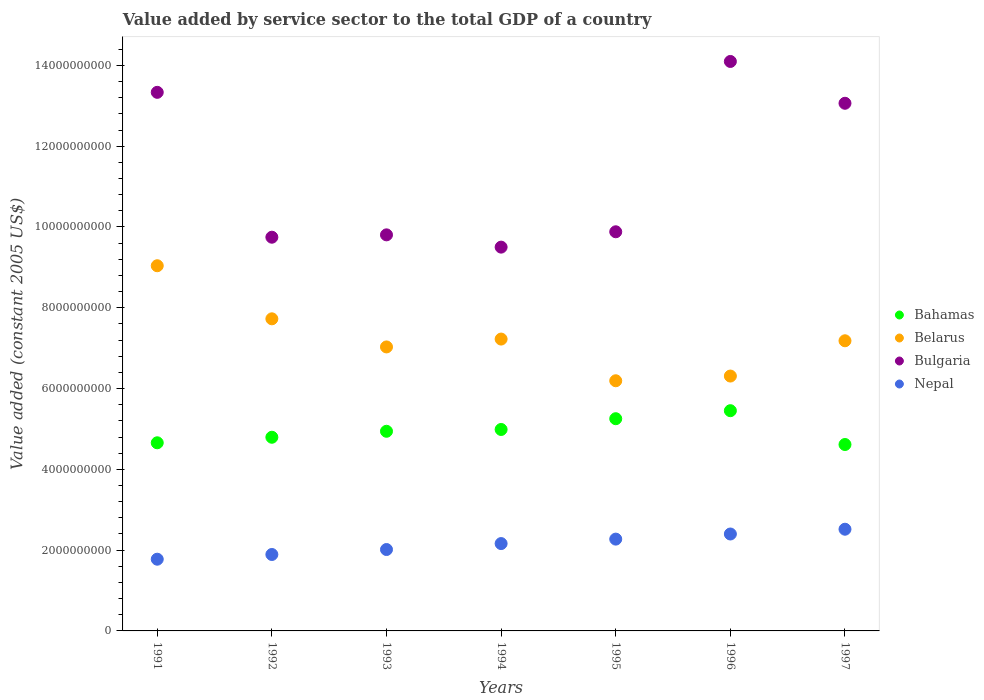What is the value added by service sector in Bulgaria in 1992?
Your answer should be very brief. 9.75e+09. Across all years, what is the maximum value added by service sector in Nepal?
Your answer should be very brief. 2.52e+09. Across all years, what is the minimum value added by service sector in Nepal?
Offer a very short reply. 1.78e+09. In which year was the value added by service sector in Nepal maximum?
Give a very brief answer. 1997. In which year was the value added by service sector in Nepal minimum?
Give a very brief answer. 1991. What is the total value added by service sector in Nepal in the graph?
Keep it short and to the point. 1.50e+1. What is the difference between the value added by service sector in Bahamas in 1992 and that in 1994?
Keep it short and to the point. -1.93e+08. What is the difference between the value added by service sector in Bahamas in 1993 and the value added by service sector in Bulgaria in 1994?
Keep it short and to the point. -4.56e+09. What is the average value added by service sector in Bahamas per year?
Provide a succinct answer. 4.96e+09. In the year 1991, what is the difference between the value added by service sector in Belarus and value added by service sector in Bulgaria?
Your response must be concise. -4.29e+09. In how many years, is the value added by service sector in Bahamas greater than 4000000000 US$?
Offer a terse response. 7. What is the ratio of the value added by service sector in Nepal in 1991 to that in 1994?
Offer a terse response. 0.82. What is the difference between the highest and the second highest value added by service sector in Bulgaria?
Your answer should be compact. 7.64e+08. What is the difference between the highest and the lowest value added by service sector in Bulgaria?
Offer a very short reply. 4.60e+09. In how many years, is the value added by service sector in Nepal greater than the average value added by service sector in Nepal taken over all years?
Your answer should be very brief. 4. Is the sum of the value added by service sector in Belarus in 1992 and 1997 greater than the maximum value added by service sector in Nepal across all years?
Make the answer very short. Yes. Is it the case that in every year, the sum of the value added by service sector in Belarus and value added by service sector in Bulgaria  is greater than the value added by service sector in Nepal?
Offer a terse response. Yes. Does the value added by service sector in Belarus monotonically increase over the years?
Make the answer very short. No. How many dotlines are there?
Your response must be concise. 4. Does the graph contain any zero values?
Ensure brevity in your answer.  No. Does the graph contain grids?
Your response must be concise. No. What is the title of the graph?
Your response must be concise. Value added by service sector to the total GDP of a country. What is the label or title of the Y-axis?
Keep it short and to the point. Value added (constant 2005 US$). What is the Value added (constant 2005 US$) of Bahamas in 1991?
Offer a terse response. 4.66e+09. What is the Value added (constant 2005 US$) of Belarus in 1991?
Your answer should be compact. 9.04e+09. What is the Value added (constant 2005 US$) of Bulgaria in 1991?
Your answer should be very brief. 1.33e+1. What is the Value added (constant 2005 US$) of Nepal in 1991?
Make the answer very short. 1.78e+09. What is the Value added (constant 2005 US$) of Bahamas in 1992?
Keep it short and to the point. 4.79e+09. What is the Value added (constant 2005 US$) of Belarus in 1992?
Ensure brevity in your answer.  7.73e+09. What is the Value added (constant 2005 US$) of Bulgaria in 1992?
Your answer should be compact. 9.75e+09. What is the Value added (constant 2005 US$) in Nepal in 1992?
Your answer should be very brief. 1.89e+09. What is the Value added (constant 2005 US$) of Bahamas in 1993?
Offer a terse response. 4.94e+09. What is the Value added (constant 2005 US$) of Belarus in 1993?
Ensure brevity in your answer.  7.03e+09. What is the Value added (constant 2005 US$) of Bulgaria in 1993?
Make the answer very short. 9.80e+09. What is the Value added (constant 2005 US$) of Nepal in 1993?
Offer a very short reply. 2.01e+09. What is the Value added (constant 2005 US$) of Bahamas in 1994?
Provide a short and direct response. 4.99e+09. What is the Value added (constant 2005 US$) in Belarus in 1994?
Offer a very short reply. 7.22e+09. What is the Value added (constant 2005 US$) of Bulgaria in 1994?
Make the answer very short. 9.50e+09. What is the Value added (constant 2005 US$) of Nepal in 1994?
Make the answer very short. 2.16e+09. What is the Value added (constant 2005 US$) of Bahamas in 1995?
Your answer should be compact. 5.25e+09. What is the Value added (constant 2005 US$) in Belarus in 1995?
Ensure brevity in your answer.  6.19e+09. What is the Value added (constant 2005 US$) of Bulgaria in 1995?
Your answer should be compact. 9.88e+09. What is the Value added (constant 2005 US$) in Nepal in 1995?
Make the answer very short. 2.27e+09. What is the Value added (constant 2005 US$) of Bahamas in 1996?
Provide a short and direct response. 5.45e+09. What is the Value added (constant 2005 US$) in Belarus in 1996?
Keep it short and to the point. 6.31e+09. What is the Value added (constant 2005 US$) of Bulgaria in 1996?
Your answer should be compact. 1.41e+1. What is the Value added (constant 2005 US$) of Nepal in 1996?
Offer a very short reply. 2.40e+09. What is the Value added (constant 2005 US$) in Bahamas in 1997?
Keep it short and to the point. 4.61e+09. What is the Value added (constant 2005 US$) of Belarus in 1997?
Keep it short and to the point. 7.18e+09. What is the Value added (constant 2005 US$) in Bulgaria in 1997?
Keep it short and to the point. 1.31e+1. What is the Value added (constant 2005 US$) in Nepal in 1997?
Make the answer very short. 2.52e+09. Across all years, what is the maximum Value added (constant 2005 US$) in Bahamas?
Your response must be concise. 5.45e+09. Across all years, what is the maximum Value added (constant 2005 US$) of Belarus?
Your answer should be very brief. 9.04e+09. Across all years, what is the maximum Value added (constant 2005 US$) of Bulgaria?
Provide a succinct answer. 1.41e+1. Across all years, what is the maximum Value added (constant 2005 US$) of Nepal?
Offer a terse response. 2.52e+09. Across all years, what is the minimum Value added (constant 2005 US$) in Bahamas?
Offer a very short reply. 4.61e+09. Across all years, what is the minimum Value added (constant 2005 US$) of Belarus?
Ensure brevity in your answer.  6.19e+09. Across all years, what is the minimum Value added (constant 2005 US$) of Bulgaria?
Make the answer very short. 9.50e+09. Across all years, what is the minimum Value added (constant 2005 US$) of Nepal?
Make the answer very short. 1.78e+09. What is the total Value added (constant 2005 US$) of Bahamas in the graph?
Keep it short and to the point. 3.47e+1. What is the total Value added (constant 2005 US$) of Belarus in the graph?
Your answer should be very brief. 5.07e+1. What is the total Value added (constant 2005 US$) in Bulgaria in the graph?
Offer a very short reply. 7.94e+1. What is the total Value added (constant 2005 US$) of Nepal in the graph?
Your response must be concise. 1.50e+1. What is the difference between the Value added (constant 2005 US$) of Bahamas in 1991 and that in 1992?
Give a very brief answer. -1.37e+08. What is the difference between the Value added (constant 2005 US$) of Belarus in 1991 and that in 1992?
Make the answer very short. 1.31e+09. What is the difference between the Value added (constant 2005 US$) of Bulgaria in 1991 and that in 1992?
Offer a very short reply. 3.59e+09. What is the difference between the Value added (constant 2005 US$) in Nepal in 1991 and that in 1992?
Provide a short and direct response. -1.17e+08. What is the difference between the Value added (constant 2005 US$) in Bahamas in 1991 and that in 1993?
Make the answer very short. -2.85e+08. What is the difference between the Value added (constant 2005 US$) of Belarus in 1991 and that in 1993?
Keep it short and to the point. 2.01e+09. What is the difference between the Value added (constant 2005 US$) of Bulgaria in 1991 and that in 1993?
Your answer should be very brief. 3.53e+09. What is the difference between the Value added (constant 2005 US$) in Nepal in 1991 and that in 1993?
Your answer should be compact. -2.40e+08. What is the difference between the Value added (constant 2005 US$) of Bahamas in 1991 and that in 1994?
Provide a succinct answer. -3.30e+08. What is the difference between the Value added (constant 2005 US$) of Belarus in 1991 and that in 1994?
Offer a terse response. 1.82e+09. What is the difference between the Value added (constant 2005 US$) in Bulgaria in 1991 and that in 1994?
Provide a succinct answer. 3.83e+09. What is the difference between the Value added (constant 2005 US$) of Nepal in 1991 and that in 1994?
Your response must be concise. -3.87e+08. What is the difference between the Value added (constant 2005 US$) of Bahamas in 1991 and that in 1995?
Keep it short and to the point. -5.96e+08. What is the difference between the Value added (constant 2005 US$) of Belarus in 1991 and that in 1995?
Provide a succinct answer. 2.85e+09. What is the difference between the Value added (constant 2005 US$) in Bulgaria in 1991 and that in 1995?
Provide a succinct answer. 3.45e+09. What is the difference between the Value added (constant 2005 US$) of Nepal in 1991 and that in 1995?
Give a very brief answer. -4.97e+08. What is the difference between the Value added (constant 2005 US$) in Bahamas in 1991 and that in 1996?
Offer a terse response. -7.95e+08. What is the difference between the Value added (constant 2005 US$) of Belarus in 1991 and that in 1996?
Your response must be concise. 2.73e+09. What is the difference between the Value added (constant 2005 US$) in Bulgaria in 1991 and that in 1996?
Your answer should be compact. -7.64e+08. What is the difference between the Value added (constant 2005 US$) in Nepal in 1991 and that in 1996?
Your answer should be very brief. -6.24e+08. What is the difference between the Value added (constant 2005 US$) in Bahamas in 1991 and that in 1997?
Make the answer very short. 4.26e+07. What is the difference between the Value added (constant 2005 US$) of Belarus in 1991 and that in 1997?
Provide a succinct answer. 1.86e+09. What is the difference between the Value added (constant 2005 US$) in Bulgaria in 1991 and that in 1997?
Your response must be concise. 2.71e+08. What is the difference between the Value added (constant 2005 US$) in Nepal in 1991 and that in 1997?
Your response must be concise. -7.42e+08. What is the difference between the Value added (constant 2005 US$) of Bahamas in 1992 and that in 1993?
Your answer should be compact. -1.48e+08. What is the difference between the Value added (constant 2005 US$) of Belarus in 1992 and that in 1993?
Offer a terse response. 6.96e+08. What is the difference between the Value added (constant 2005 US$) of Bulgaria in 1992 and that in 1993?
Ensure brevity in your answer.  -5.85e+07. What is the difference between the Value added (constant 2005 US$) in Nepal in 1992 and that in 1993?
Your response must be concise. -1.23e+08. What is the difference between the Value added (constant 2005 US$) in Bahamas in 1992 and that in 1994?
Offer a very short reply. -1.93e+08. What is the difference between the Value added (constant 2005 US$) in Belarus in 1992 and that in 1994?
Provide a short and direct response. 5.01e+08. What is the difference between the Value added (constant 2005 US$) in Bulgaria in 1992 and that in 1994?
Your answer should be very brief. 2.45e+08. What is the difference between the Value added (constant 2005 US$) in Nepal in 1992 and that in 1994?
Provide a short and direct response. -2.70e+08. What is the difference between the Value added (constant 2005 US$) in Bahamas in 1992 and that in 1995?
Make the answer very short. -4.59e+08. What is the difference between the Value added (constant 2005 US$) in Belarus in 1992 and that in 1995?
Provide a short and direct response. 1.53e+09. What is the difference between the Value added (constant 2005 US$) in Bulgaria in 1992 and that in 1995?
Give a very brief answer. -1.35e+08. What is the difference between the Value added (constant 2005 US$) in Nepal in 1992 and that in 1995?
Offer a very short reply. -3.81e+08. What is the difference between the Value added (constant 2005 US$) of Bahamas in 1992 and that in 1996?
Ensure brevity in your answer.  -6.57e+08. What is the difference between the Value added (constant 2005 US$) of Belarus in 1992 and that in 1996?
Offer a terse response. 1.42e+09. What is the difference between the Value added (constant 2005 US$) in Bulgaria in 1992 and that in 1996?
Ensure brevity in your answer.  -4.35e+09. What is the difference between the Value added (constant 2005 US$) of Nepal in 1992 and that in 1996?
Make the answer very short. -5.07e+08. What is the difference between the Value added (constant 2005 US$) of Bahamas in 1992 and that in 1997?
Make the answer very short. 1.80e+08. What is the difference between the Value added (constant 2005 US$) in Belarus in 1992 and that in 1997?
Provide a short and direct response. 5.43e+08. What is the difference between the Value added (constant 2005 US$) in Bulgaria in 1992 and that in 1997?
Your response must be concise. -3.32e+09. What is the difference between the Value added (constant 2005 US$) in Nepal in 1992 and that in 1997?
Make the answer very short. -6.26e+08. What is the difference between the Value added (constant 2005 US$) of Bahamas in 1993 and that in 1994?
Make the answer very short. -4.47e+07. What is the difference between the Value added (constant 2005 US$) of Belarus in 1993 and that in 1994?
Make the answer very short. -1.95e+08. What is the difference between the Value added (constant 2005 US$) in Bulgaria in 1993 and that in 1994?
Provide a short and direct response. 3.04e+08. What is the difference between the Value added (constant 2005 US$) in Nepal in 1993 and that in 1994?
Make the answer very short. -1.47e+08. What is the difference between the Value added (constant 2005 US$) of Bahamas in 1993 and that in 1995?
Make the answer very short. -3.11e+08. What is the difference between the Value added (constant 2005 US$) in Belarus in 1993 and that in 1995?
Provide a succinct answer. 8.37e+08. What is the difference between the Value added (constant 2005 US$) of Bulgaria in 1993 and that in 1995?
Provide a succinct answer. -7.61e+07. What is the difference between the Value added (constant 2005 US$) of Nepal in 1993 and that in 1995?
Make the answer very short. -2.58e+08. What is the difference between the Value added (constant 2005 US$) in Bahamas in 1993 and that in 1996?
Ensure brevity in your answer.  -5.10e+08. What is the difference between the Value added (constant 2005 US$) in Belarus in 1993 and that in 1996?
Your response must be concise. 7.21e+08. What is the difference between the Value added (constant 2005 US$) in Bulgaria in 1993 and that in 1996?
Ensure brevity in your answer.  -4.29e+09. What is the difference between the Value added (constant 2005 US$) in Nepal in 1993 and that in 1996?
Offer a terse response. -3.84e+08. What is the difference between the Value added (constant 2005 US$) of Bahamas in 1993 and that in 1997?
Give a very brief answer. 3.28e+08. What is the difference between the Value added (constant 2005 US$) of Belarus in 1993 and that in 1997?
Provide a short and direct response. -1.52e+08. What is the difference between the Value added (constant 2005 US$) in Bulgaria in 1993 and that in 1997?
Make the answer very short. -3.26e+09. What is the difference between the Value added (constant 2005 US$) of Nepal in 1993 and that in 1997?
Make the answer very short. -5.03e+08. What is the difference between the Value added (constant 2005 US$) of Bahamas in 1994 and that in 1995?
Provide a short and direct response. -2.67e+08. What is the difference between the Value added (constant 2005 US$) of Belarus in 1994 and that in 1995?
Provide a succinct answer. 1.03e+09. What is the difference between the Value added (constant 2005 US$) of Bulgaria in 1994 and that in 1995?
Offer a very short reply. -3.80e+08. What is the difference between the Value added (constant 2005 US$) of Nepal in 1994 and that in 1995?
Your answer should be very brief. -1.10e+08. What is the difference between the Value added (constant 2005 US$) in Bahamas in 1994 and that in 1996?
Your response must be concise. -4.65e+08. What is the difference between the Value added (constant 2005 US$) in Belarus in 1994 and that in 1996?
Your answer should be compact. 9.15e+08. What is the difference between the Value added (constant 2005 US$) of Bulgaria in 1994 and that in 1996?
Ensure brevity in your answer.  -4.60e+09. What is the difference between the Value added (constant 2005 US$) in Nepal in 1994 and that in 1996?
Ensure brevity in your answer.  -2.37e+08. What is the difference between the Value added (constant 2005 US$) in Bahamas in 1994 and that in 1997?
Offer a very short reply. 3.72e+08. What is the difference between the Value added (constant 2005 US$) in Belarus in 1994 and that in 1997?
Offer a terse response. 4.22e+07. What is the difference between the Value added (constant 2005 US$) of Bulgaria in 1994 and that in 1997?
Offer a very short reply. -3.56e+09. What is the difference between the Value added (constant 2005 US$) of Nepal in 1994 and that in 1997?
Ensure brevity in your answer.  -3.55e+08. What is the difference between the Value added (constant 2005 US$) of Bahamas in 1995 and that in 1996?
Your answer should be very brief. -1.98e+08. What is the difference between the Value added (constant 2005 US$) in Belarus in 1995 and that in 1996?
Your answer should be very brief. -1.17e+08. What is the difference between the Value added (constant 2005 US$) of Bulgaria in 1995 and that in 1996?
Your answer should be very brief. -4.22e+09. What is the difference between the Value added (constant 2005 US$) of Nepal in 1995 and that in 1996?
Provide a succinct answer. -1.27e+08. What is the difference between the Value added (constant 2005 US$) of Bahamas in 1995 and that in 1997?
Ensure brevity in your answer.  6.39e+08. What is the difference between the Value added (constant 2005 US$) in Belarus in 1995 and that in 1997?
Your response must be concise. -9.90e+08. What is the difference between the Value added (constant 2005 US$) in Bulgaria in 1995 and that in 1997?
Your answer should be compact. -3.18e+09. What is the difference between the Value added (constant 2005 US$) of Nepal in 1995 and that in 1997?
Provide a short and direct response. -2.45e+08. What is the difference between the Value added (constant 2005 US$) in Bahamas in 1996 and that in 1997?
Provide a short and direct response. 8.37e+08. What is the difference between the Value added (constant 2005 US$) of Belarus in 1996 and that in 1997?
Your answer should be compact. -8.73e+08. What is the difference between the Value added (constant 2005 US$) of Bulgaria in 1996 and that in 1997?
Keep it short and to the point. 1.03e+09. What is the difference between the Value added (constant 2005 US$) in Nepal in 1996 and that in 1997?
Provide a succinct answer. -1.18e+08. What is the difference between the Value added (constant 2005 US$) of Bahamas in 1991 and the Value added (constant 2005 US$) of Belarus in 1992?
Your answer should be compact. -3.07e+09. What is the difference between the Value added (constant 2005 US$) of Bahamas in 1991 and the Value added (constant 2005 US$) of Bulgaria in 1992?
Your answer should be very brief. -5.09e+09. What is the difference between the Value added (constant 2005 US$) in Bahamas in 1991 and the Value added (constant 2005 US$) in Nepal in 1992?
Give a very brief answer. 2.77e+09. What is the difference between the Value added (constant 2005 US$) of Belarus in 1991 and the Value added (constant 2005 US$) of Bulgaria in 1992?
Ensure brevity in your answer.  -7.06e+08. What is the difference between the Value added (constant 2005 US$) of Belarus in 1991 and the Value added (constant 2005 US$) of Nepal in 1992?
Make the answer very short. 7.15e+09. What is the difference between the Value added (constant 2005 US$) of Bulgaria in 1991 and the Value added (constant 2005 US$) of Nepal in 1992?
Offer a very short reply. 1.14e+1. What is the difference between the Value added (constant 2005 US$) of Bahamas in 1991 and the Value added (constant 2005 US$) of Belarus in 1993?
Provide a succinct answer. -2.37e+09. What is the difference between the Value added (constant 2005 US$) in Bahamas in 1991 and the Value added (constant 2005 US$) in Bulgaria in 1993?
Provide a succinct answer. -5.15e+09. What is the difference between the Value added (constant 2005 US$) of Bahamas in 1991 and the Value added (constant 2005 US$) of Nepal in 1993?
Ensure brevity in your answer.  2.64e+09. What is the difference between the Value added (constant 2005 US$) of Belarus in 1991 and the Value added (constant 2005 US$) of Bulgaria in 1993?
Offer a very short reply. -7.65e+08. What is the difference between the Value added (constant 2005 US$) in Belarus in 1991 and the Value added (constant 2005 US$) in Nepal in 1993?
Keep it short and to the point. 7.03e+09. What is the difference between the Value added (constant 2005 US$) of Bulgaria in 1991 and the Value added (constant 2005 US$) of Nepal in 1993?
Offer a terse response. 1.13e+1. What is the difference between the Value added (constant 2005 US$) of Bahamas in 1991 and the Value added (constant 2005 US$) of Belarus in 1994?
Give a very brief answer. -2.57e+09. What is the difference between the Value added (constant 2005 US$) in Bahamas in 1991 and the Value added (constant 2005 US$) in Bulgaria in 1994?
Give a very brief answer. -4.84e+09. What is the difference between the Value added (constant 2005 US$) of Bahamas in 1991 and the Value added (constant 2005 US$) of Nepal in 1994?
Give a very brief answer. 2.49e+09. What is the difference between the Value added (constant 2005 US$) of Belarus in 1991 and the Value added (constant 2005 US$) of Bulgaria in 1994?
Offer a very short reply. -4.61e+08. What is the difference between the Value added (constant 2005 US$) of Belarus in 1991 and the Value added (constant 2005 US$) of Nepal in 1994?
Your response must be concise. 6.88e+09. What is the difference between the Value added (constant 2005 US$) in Bulgaria in 1991 and the Value added (constant 2005 US$) in Nepal in 1994?
Your answer should be very brief. 1.12e+1. What is the difference between the Value added (constant 2005 US$) of Bahamas in 1991 and the Value added (constant 2005 US$) of Belarus in 1995?
Ensure brevity in your answer.  -1.54e+09. What is the difference between the Value added (constant 2005 US$) in Bahamas in 1991 and the Value added (constant 2005 US$) in Bulgaria in 1995?
Provide a succinct answer. -5.22e+09. What is the difference between the Value added (constant 2005 US$) of Bahamas in 1991 and the Value added (constant 2005 US$) of Nepal in 1995?
Offer a terse response. 2.38e+09. What is the difference between the Value added (constant 2005 US$) in Belarus in 1991 and the Value added (constant 2005 US$) in Bulgaria in 1995?
Provide a succinct answer. -8.41e+08. What is the difference between the Value added (constant 2005 US$) of Belarus in 1991 and the Value added (constant 2005 US$) of Nepal in 1995?
Provide a short and direct response. 6.77e+09. What is the difference between the Value added (constant 2005 US$) of Bulgaria in 1991 and the Value added (constant 2005 US$) of Nepal in 1995?
Offer a very short reply. 1.11e+1. What is the difference between the Value added (constant 2005 US$) of Bahamas in 1991 and the Value added (constant 2005 US$) of Belarus in 1996?
Ensure brevity in your answer.  -1.65e+09. What is the difference between the Value added (constant 2005 US$) in Bahamas in 1991 and the Value added (constant 2005 US$) in Bulgaria in 1996?
Your response must be concise. -9.44e+09. What is the difference between the Value added (constant 2005 US$) in Bahamas in 1991 and the Value added (constant 2005 US$) in Nepal in 1996?
Keep it short and to the point. 2.26e+09. What is the difference between the Value added (constant 2005 US$) in Belarus in 1991 and the Value added (constant 2005 US$) in Bulgaria in 1996?
Your response must be concise. -5.06e+09. What is the difference between the Value added (constant 2005 US$) in Belarus in 1991 and the Value added (constant 2005 US$) in Nepal in 1996?
Make the answer very short. 6.64e+09. What is the difference between the Value added (constant 2005 US$) in Bulgaria in 1991 and the Value added (constant 2005 US$) in Nepal in 1996?
Keep it short and to the point. 1.09e+1. What is the difference between the Value added (constant 2005 US$) of Bahamas in 1991 and the Value added (constant 2005 US$) of Belarus in 1997?
Make the answer very short. -2.53e+09. What is the difference between the Value added (constant 2005 US$) in Bahamas in 1991 and the Value added (constant 2005 US$) in Bulgaria in 1997?
Offer a terse response. -8.40e+09. What is the difference between the Value added (constant 2005 US$) in Bahamas in 1991 and the Value added (constant 2005 US$) in Nepal in 1997?
Your answer should be compact. 2.14e+09. What is the difference between the Value added (constant 2005 US$) in Belarus in 1991 and the Value added (constant 2005 US$) in Bulgaria in 1997?
Your answer should be compact. -4.02e+09. What is the difference between the Value added (constant 2005 US$) of Belarus in 1991 and the Value added (constant 2005 US$) of Nepal in 1997?
Provide a short and direct response. 6.52e+09. What is the difference between the Value added (constant 2005 US$) of Bulgaria in 1991 and the Value added (constant 2005 US$) of Nepal in 1997?
Provide a succinct answer. 1.08e+1. What is the difference between the Value added (constant 2005 US$) in Bahamas in 1992 and the Value added (constant 2005 US$) in Belarus in 1993?
Offer a terse response. -2.24e+09. What is the difference between the Value added (constant 2005 US$) of Bahamas in 1992 and the Value added (constant 2005 US$) of Bulgaria in 1993?
Your answer should be very brief. -5.01e+09. What is the difference between the Value added (constant 2005 US$) of Bahamas in 1992 and the Value added (constant 2005 US$) of Nepal in 1993?
Keep it short and to the point. 2.78e+09. What is the difference between the Value added (constant 2005 US$) of Belarus in 1992 and the Value added (constant 2005 US$) of Bulgaria in 1993?
Give a very brief answer. -2.08e+09. What is the difference between the Value added (constant 2005 US$) of Belarus in 1992 and the Value added (constant 2005 US$) of Nepal in 1993?
Offer a terse response. 5.71e+09. What is the difference between the Value added (constant 2005 US$) of Bulgaria in 1992 and the Value added (constant 2005 US$) of Nepal in 1993?
Offer a terse response. 7.73e+09. What is the difference between the Value added (constant 2005 US$) in Bahamas in 1992 and the Value added (constant 2005 US$) in Belarus in 1994?
Give a very brief answer. -2.43e+09. What is the difference between the Value added (constant 2005 US$) of Bahamas in 1992 and the Value added (constant 2005 US$) of Bulgaria in 1994?
Give a very brief answer. -4.71e+09. What is the difference between the Value added (constant 2005 US$) in Bahamas in 1992 and the Value added (constant 2005 US$) in Nepal in 1994?
Give a very brief answer. 2.63e+09. What is the difference between the Value added (constant 2005 US$) of Belarus in 1992 and the Value added (constant 2005 US$) of Bulgaria in 1994?
Your answer should be very brief. -1.77e+09. What is the difference between the Value added (constant 2005 US$) in Belarus in 1992 and the Value added (constant 2005 US$) in Nepal in 1994?
Your answer should be compact. 5.56e+09. What is the difference between the Value added (constant 2005 US$) of Bulgaria in 1992 and the Value added (constant 2005 US$) of Nepal in 1994?
Ensure brevity in your answer.  7.58e+09. What is the difference between the Value added (constant 2005 US$) in Bahamas in 1992 and the Value added (constant 2005 US$) in Belarus in 1995?
Give a very brief answer. -1.40e+09. What is the difference between the Value added (constant 2005 US$) of Bahamas in 1992 and the Value added (constant 2005 US$) of Bulgaria in 1995?
Your answer should be very brief. -5.09e+09. What is the difference between the Value added (constant 2005 US$) in Bahamas in 1992 and the Value added (constant 2005 US$) in Nepal in 1995?
Keep it short and to the point. 2.52e+09. What is the difference between the Value added (constant 2005 US$) in Belarus in 1992 and the Value added (constant 2005 US$) in Bulgaria in 1995?
Your answer should be compact. -2.15e+09. What is the difference between the Value added (constant 2005 US$) of Belarus in 1992 and the Value added (constant 2005 US$) of Nepal in 1995?
Make the answer very short. 5.45e+09. What is the difference between the Value added (constant 2005 US$) of Bulgaria in 1992 and the Value added (constant 2005 US$) of Nepal in 1995?
Offer a very short reply. 7.47e+09. What is the difference between the Value added (constant 2005 US$) in Bahamas in 1992 and the Value added (constant 2005 US$) in Belarus in 1996?
Provide a short and direct response. -1.52e+09. What is the difference between the Value added (constant 2005 US$) in Bahamas in 1992 and the Value added (constant 2005 US$) in Bulgaria in 1996?
Provide a short and direct response. -9.30e+09. What is the difference between the Value added (constant 2005 US$) in Bahamas in 1992 and the Value added (constant 2005 US$) in Nepal in 1996?
Make the answer very short. 2.39e+09. What is the difference between the Value added (constant 2005 US$) of Belarus in 1992 and the Value added (constant 2005 US$) of Bulgaria in 1996?
Your answer should be very brief. -6.37e+09. What is the difference between the Value added (constant 2005 US$) in Belarus in 1992 and the Value added (constant 2005 US$) in Nepal in 1996?
Offer a very short reply. 5.33e+09. What is the difference between the Value added (constant 2005 US$) of Bulgaria in 1992 and the Value added (constant 2005 US$) of Nepal in 1996?
Keep it short and to the point. 7.35e+09. What is the difference between the Value added (constant 2005 US$) in Bahamas in 1992 and the Value added (constant 2005 US$) in Belarus in 1997?
Your response must be concise. -2.39e+09. What is the difference between the Value added (constant 2005 US$) of Bahamas in 1992 and the Value added (constant 2005 US$) of Bulgaria in 1997?
Keep it short and to the point. -8.27e+09. What is the difference between the Value added (constant 2005 US$) of Bahamas in 1992 and the Value added (constant 2005 US$) of Nepal in 1997?
Keep it short and to the point. 2.28e+09. What is the difference between the Value added (constant 2005 US$) in Belarus in 1992 and the Value added (constant 2005 US$) in Bulgaria in 1997?
Give a very brief answer. -5.34e+09. What is the difference between the Value added (constant 2005 US$) of Belarus in 1992 and the Value added (constant 2005 US$) of Nepal in 1997?
Make the answer very short. 5.21e+09. What is the difference between the Value added (constant 2005 US$) of Bulgaria in 1992 and the Value added (constant 2005 US$) of Nepal in 1997?
Give a very brief answer. 7.23e+09. What is the difference between the Value added (constant 2005 US$) in Bahamas in 1993 and the Value added (constant 2005 US$) in Belarus in 1994?
Provide a short and direct response. -2.28e+09. What is the difference between the Value added (constant 2005 US$) of Bahamas in 1993 and the Value added (constant 2005 US$) of Bulgaria in 1994?
Give a very brief answer. -4.56e+09. What is the difference between the Value added (constant 2005 US$) in Bahamas in 1993 and the Value added (constant 2005 US$) in Nepal in 1994?
Provide a succinct answer. 2.78e+09. What is the difference between the Value added (constant 2005 US$) in Belarus in 1993 and the Value added (constant 2005 US$) in Bulgaria in 1994?
Ensure brevity in your answer.  -2.47e+09. What is the difference between the Value added (constant 2005 US$) of Belarus in 1993 and the Value added (constant 2005 US$) of Nepal in 1994?
Keep it short and to the point. 4.87e+09. What is the difference between the Value added (constant 2005 US$) of Bulgaria in 1993 and the Value added (constant 2005 US$) of Nepal in 1994?
Provide a short and direct response. 7.64e+09. What is the difference between the Value added (constant 2005 US$) in Bahamas in 1993 and the Value added (constant 2005 US$) in Belarus in 1995?
Your answer should be compact. -1.25e+09. What is the difference between the Value added (constant 2005 US$) in Bahamas in 1993 and the Value added (constant 2005 US$) in Bulgaria in 1995?
Keep it short and to the point. -4.94e+09. What is the difference between the Value added (constant 2005 US$) in Bahamas in 1993 and the Value added (constant 2005 US$) in Nepal in 1995?
Your answer should be compact. 2.67e+09. What is the difference between the Value added (constant 2005 US$) of Belarus in 1993 and the Value added (constant 2005 US$) of Bulgaria in 1995?
Provide a short and direct response. -2.85e+09. What is the difference between the Value added (constant 2005 US$) of Belarus in 1993 and the Value added (constant 2005 US$) of Nepal in 1995?
Give a very brief answer. 4.76e+09. What is the difference between the Value added (constant 2005 US$) of Bulgaria in 1993 and the Value added (constant 2005 US$) of Nepal in 1995?
Your answer should be compact. 7.53e+09. What is the difference between the Value added (constant 2005 US$) in Bahamas in 1993 and the Value added (constant 2005 US$) in Belarus in 1996?
Your response must be concise. -1.37e+09. What is the difference between the Value added (constant 2005 US$) of Bahamas in 1993 and the Value added (constant 2005 US$) of Bulgaria in 1996?
Keep it short and to the point. -9.15e+09. What is the difference between the Value added (constant 2005 US$) of Bahamas in 1993 and the Value added (constant 2005 US$) of Nepal in 1996?
Make the answer very short. 2.54e+09. What is the difference between the Value added (constant 2005 US$) of Belarus in 1993 and the Value added (constant 2005 US$) of Bulgaria in 1996?
Provide a short and direct response. -7.07e+09. What is the difference between the Value added (constant 2005 US$) of Belarus in 1993 and the Value added (constant 2005 US$) of Nepal in 1996?
Offer a terse response. 4.63e+09. What is the difference between the Value added (constant 2005 US$) in Bulgaria in 1993 and the Value added (constant 2005 US$) in Nepal in 1996?
Your response must be concise. 7.41e+09. What is the difference between the Value added (constant 2005 US$) of Bahamas in 1993 and the Value added (constant 2005 US$) of Belarus in 1997?
Offer a terse response. -2.24e+09. What is the difference between the Value added (constant 2005 US$) in Bahamas in 1993 and the Value added (constant 2005 US$) in Bulgaria in 1997?
Provide a short and direct response. -8.12e+09. What is the difference between the Value added (constant 2005 US$) of Bahamas in 1993 and the Value added (constant 2005 US$) of Nepal in 1997?
Your answer should be very brief. 2.42e+09. What is the difference between the Value added (constant 2005 US$) of Belarus in 1993 and the Value added (constant 2005 US$) of Bulgaria in 1997?
Provide a succinct answer. -6.03e+09. What is the difference between the Value added (constant 2005 US$) in Belarus in 1993 and the Value added (constant 2005 US$) in Nepal in 1997?
Ensure brevity in your answer.  4.51e+09. What is the difference between the Value added (constant 2005 US$) in Bulgaria in 1993 and the Value added (constant 2005 US$) in Nepal in 1997?
Offer a terse response. 7.29e+09. What is the difference between the Value added (constant 2005 US$) of Bahamas in 1994 and the Value added (constant 2005 US$) of Belarus in 1995?
Your answer should be compact. -1.21e+09. What is the difference between the Value added (constant 2005 US$) of Bahamas in 1994 and the Value added (constant 2005 US$) of Bulgaria in 1995?
Give a very brief answer. -4.89e+09. What is the difference between the Value added (constant 2005 US$) of Bahamas in 1994 and the Value added (constant 2005 US$) of Nepal in 1995?
Your answer should be compact. 2.71e+09. What is the difference between the Value added (constant 2005 US$) of Belarus in 1994 and the Value added (constant 2005 US$) of Bulgaria in 1995?
Provide a succinct answer. -2.66e+09. What is the difference between the Value added (constant 2005 US$) in Belarus in 1994 and the Value added (constant 2005 US$) in Nepal in 1995?
Provide a succinct answer. 4.95e+09. What is the difference between the Value added (constant 2005 US$) in Bulgaria in 1994 and the Value added (constant 2005 US$) in Nepal in 1995?
Provide a short and direct response. 7.23e+09. What is the difference between the Value added (constant 2005 US$) in Bahamas in 1994 and the Value added (constant 2005 US$) in Belarus in 1996?
Offer a terse response. -1.32e+09. What is the difference between the Value added (constant 2005 US$) in Bahamas in 1994 and the Value added (constant 2005 US$) in Bulgaria in 1996?
Keep it short and to the point. -9.11e+09. What is the difference between the Value added (constant 2005 US$) in Bahamas in 1994 and the Value added (constant 2005 US$) in Nepal in 1996?
Offer a terse response. 2.59e+09. What is the difference between the Value added (constant 2005 US$) of Belarus in 1994 and the Value added (constant 2005 US$) of Bulgaria in 1996?
Offer a very short reply. -6.87e+09. What is the difference between the Value added (constant 2005 US$) in Belarus in 1994 and the Value added (constant 2005 US$) in Nepal in 1996?
Your answer should be very brief. 4.83e+09. What is the difference between the Value added (constant 2005 US$) of Bulgaria in 1994 and the Value added (constant 2005 US$) of Nepal in 1996?
Offer a very short reply. 7.10e+09. What is the difference between the Value added (constant 2005 US$) in Bahamas in 1994 and the Value added (constant 2005 US$) in Belarus in 1997?
Provide a short and direct response. -2.20e+09. What is the difference between the Value added (constant 2005 US$) in Bahamas in 1994 and the Value added (constant 2005 US$) in Bulgaria in 1997?
Offer a very short reply. -8.08e+09. What is the difference between the Value added (constant 2005 US$) of Bahamas in 1994 and the Value added (constant 2005 US$) of Nepal in 1997?
Your response must be concise. 2.47e+09. What is the difference between the Value added (constant 2005 US$) of Belarus in 1994 and the Value added (constant 2005 US$) of Bulgaria in 1997?
Ensure brevity in your answer.  -5.84e+09. What is the difference between the Value added (constant 2005 US$) in Belarus in 1994 and the Value added (constant 2005 US$) in Nepal in 1997?
Make the answer very short. 4.71e+09. What is the difference between the Value added (constant 2005 US$) of Bulgaria in 1994 and the Value added (constant 2005 US$) of Nepal in 1997?
Ensure brevity in your answer.  6.98e+09. What is the difference between the Value added (constant 2005 US$) in Bahamas in 1995 and the Value added (constant 2005 US$) in Belarus in 1996?
Keep it short and to the point. -1.06e+09. What is the difference between the Value added (constant 2005 US$) of Bahamas in 1995 and the Value added (constant 2005 US$) of Bulgaria in 1996?
Make the answer very short. -8.84e+09. What is the difference between the Value added (constant 2005 US$) in Bahamas in 1995 and the Value added (constant 2005 US$) in Nepal in 1996?
Give a very brief answer. 2.85e+09. What is the difference between the Value added (constant 2005 US$) in Belarus in 1995 and the Value added (constant 2005 US$) in Bulgaria in 1996?
Provide a short and direct response. -7.90e+09. What is the difference between the Value added (constant 2005 US$) in Belarus in 1995 and the Value added (constant 2005 US$) in Nepal in 1996?
Give a very brief answer. 3.79e+09. What is the difference between the Value added (constant 2005 US$) in Bulgaria in 1995 and the Value added (constant 2005 US$) in Nepal in 1996?
Offer a terse response. 7.48e+09. What is the difference between the Value added (constant 2005 US$) of Bahamas in 1995 and the Value added (constant 2005 US$) of Belarus in 1997?
Offer a very short reply. -1.93e+09. What is the difference between the Value added (constant 2005 US$) in Bahamas in 1995 and the Value added (constant 2005 US$) in Bulgaria in 1997?
Ensure brevity in your answer.  -7.81e+09. What is the difference between the Value added (constant 2005 US$) in Bahamas in 1995 and the Value added (constant 2005 US$) in Nepal in 1997?
Make the answer very short. 2.74e+09. What is the difference between the Value added (constant 2005 US$) in Belarus in 1995 and the Value added (constant 2005 US$) in Bulgaria in 1997?
Offer a terse response. -6.87e+09. What is the difference between the Value added (constant 2005 US$) in Belarus in 1995 and the Value added (constant 2005 US$) in Nepal in 1997?
Your response must be concise. 3.68e+09. What is the difference between the Value added (constant 2005 US$) in Bulgaria in 1995 and the Value added (constant 2005 US$) in Nepal in 1997?
Offer a very short reply. 7.36e+09. What is the difference between the Value added (constant 2005 US$) in Bahamas in 1996 and the Value added (constant 2005 US$) in Belarus in 1997?
Make the answer very short. -1.73e+09. What is the difference between the Value added (constant 2005 US$) of Bahamas in 1996 and the Value added (constant 2005 US$) of Bulgaria in 1997?
Keep it short and to the point. -7.61e+09. What is the difference between the Value added (constant 2005 US$) in Bahamas in 1996 and the Value added (constant 2005 US$) in Nepal in 1997?
Provide a succinct answer. 2.93e+09. What is the difference between the Value added (constant 2005 US$) of Belarus in 1996 and the Value added (constant 2005 US$) of Bulgaria in 1997?
Your answer should be compact. -6.75e+09. What is the difference between the Value added (constant 2005 US$) of Belarus in 1996 and the Value added (constant 2005 US$) of Nepal in 1997?
Offer a terse response. 3.79e+09. What is the difference between the Value added (constant 2005 US$) of Bulgaria in 1996 and the Value added (constant 2005 US$) of Nepal in 1997?
Your answer should be very brief. 1.16e+1. What is the average Value added (constant 2005 US$) of Bahamas per year?
Make the answer very short. 4.96e+09. What is the average Value added (constant 2005 US$) in Belarus per year?
Provide a succinct answer. 7.24e+09. What is the average Value added (constant 2005 US$) in Bulgaria per year?
Offer a terse response. 1.13e+1. What is the average Value added (constant 2005 US$) of Nepal per year?
Your answer should be compact. 2.15e+09. In the year 1991, what is the difference between the Value added (constant 2005 US$) in Bahamas and Value added (constant 2005 US$) in Belarus?
Your answer should be very brief. -4.38e+09. In the year 1991, what is the difference between the Value added (constant 2005 US$) in Bahamas and Value added (constant 2005 US$) in Bulgaria?
Give a very brief answer. -8.68e+09. In the year 1991, what is the difference between the Value added (constant 2005 US$) of Bahamas and Value added (constant 2005 US$) of Nepal?
Provide a short and direct response. 2.88e+09. In the year 1991, what is the difference between the Value added (constant 2005 US$) in Belarus and Value added (constant 2005 US$) in Bulgaria?
Give a very brief answer. -4.29e+09. In the year 1991, what is the difference between the Value added (constant 2005 US$) of Belarus and Value added (constant 2005 US$) of Nepal?
Your answer should be compact. 7.26e+09. In the year 1991, what is the difference between the Value added (constant 2005 US$) in Bulgaria and Value added (constant 2005 US$) in Nepal?
Provide a short and direct response. 1.16e+1. In the year 1992, what is the difference between the Value added (constant 2005 US$) of Bahamas and Value added (constant 2005 US$) of Belarus?
Ensure brevity in your answer.  -2.93e+09. In the year 1992, what is the difference between the Value added (constant 2005 US$) in Bahamas and Value added (constant 2005 US$) in Bulgaria?
Your answer should be compact. -4.95e+09. In the year 1992, what is the difference between the Value added (constant 2005 US$) of Bahamas and Value added (constant 2005 US$) of Nepal?
Provide a succinct answer. 2.90e+09. In the year 1992, what is the difference between the Value added (constant 2005 US$) of Belarus and Value added (constant 2005 US$) of Bulgaria?
Your answer should be compact. -2.02e+09. In the year 1992, what is the difference between the Value added (constant 2005 US$) in Belarus and Value added (constant 2005 US$) in Nepal?
Make the answer very short. 5.83e+09. In the year 1992, what is the difference between the Value added (constant 2005 US$) of Bulgaria and Value added (constant 2005 US$) of Nepal?
Offer a terse response. 7.85e+09. In the year 1993, what is the difference between the Value added (constant 2005 US$) of Bahamas and Value added (constant 2005 US$) of Belarus?
Give a very brief answer. -2.09e+09. In the year 1993, what is the difference between the Value added (constant 2005 US$) in Bahamas and Value added (constant 2005 US$) in Bulgaria?
Your answer should be very brief. -4.86e+09. In the year 1993, what is the difference between the Value added (constant 2005 US$) in Bahamas and Value added (constant 2005 US$) in Nepal?
Provide a succinct answer. 2.93e+09. In the year 1993, what is the difference between the Value added (constant 2005 US$) in Belarus and Value added (constant 2005 US$) in Bulgaria?
Provide a succinct answer. -2.77e+09. In the year 1993, what is the difference between the Value added (constant 2005 US$) in Belarus and Value added (constant 2005 US$) in Nepal?
Your answer should be very brief. 5.02e+09. In the year 1993, what is the difference between the Value added (constant 2005 US$) of Bulgaria and Value added (constant 2005 US$) of Nepal?
Provide a succinct answer. 7.79e+09. In the year 1994, what is the difference between the Value added (constant 2005 US$) in Bahamas and Value added (constant 2005 US$) in Belarus?
Your response must be concise. -2.24e+09. In the year 1994, what is the difference between the Value added (constant 2005 US$) of Bahamas and Value added (constant 2005 US$) of Bulgaria?
Ensure brevity in your answer.  -4.51e+09. In the year 1994, what is the difference between the Value added (constant 2005 US$) in Bahamas and Value added (constant 2005 US$) in Nepal?
Provide a short and direct response. 2.82e+09. In the year 1994, what is the difference between the Value added (constant 2005 US$) of Belarus and Value added (constant 2005 US$) of Bulgaria?
Provide a short and direct response. -2.28e+09. In the year 1994, what is the difference between the Value added (constant 2005 US$) of Belarus and Value added (constant 2005 US$) of Nepal?
Make the answer very short. 5.06e+09. In the year 1994, what is the difference between the Value added (constant 2005 US$) of Bulgaria and Value added (constant 2005 US$) of Nepal?
Your answer should be very brief. 7.34e+09. In the year 1995, what is the difference between the Value added (constant 2005 US$) of Bahamas and Value added (constant 2005 US$) of Belarus?
Provide a succinct answer. -9.39e+08. In the year 1995, what is the difference between the Value added (constant 2005 US$) in Bahamas and Value added (constant 2005 US$) in Bulgaria?
Provide a succinct answer. -4.63e+09. In the year 1995, what is the difference between the Value added (constant 2005 US$) of Bahamas and Value added (constant 2005 US$) of Nepal?
Your response must be concise. 2.98e+09. In the year 1995, what is the difference between the Value added (constant 2005 US$) of Belarus and Value added (constant 2005 US$) of Bulgaria?
Ensure brevity in your answer.  -3.69e+09. In the year 1995, what is the difference between the Value added (constant 2005 US$) in Belarus and Value added (constant 2005 US$) in Nepal?
Ensure brevity in your answer.  3.92e+09. In the year 1995, what is the difference between the Value added (constant 2005 US$) of Bulgaria and Value added (constant 2005 US$) of Nepal?
Provide a succinct answer. 7.61e+09. In the year 1996, what is the difference between the Value added (constant 2005 US$) of Bahamas and Value added (constant 2005 US$) of Belarus?
Offer a very short reply. -8.58e+08. In the year 1996, what is the difference between the Value added (constant 2005 US$) of Bahamas and Value added (constant 2005 US$) of Bulgaria?
Your answer should be very brief. -8.65e+09. In the year 1996, what is the difference between the Value added (constant 2005 US$) of Bahamas and Value added (constant 2005 US$) of Nepal?
Provide a succinct answer. 3.05e+09. In the year 1996, what is the difference between the Value added (constant 2005 US$) in Belarus and Value added (constant 2005 US$) in Bulgaria?
Give a very brief answer. -7.79e+09. In the year 1996, what is the difference between the Value added (constant 2005 US$) of Belarus and Value added (constant 2005 US$) of Nepal?
Your answer should be compact. 3.91e+09. In the year 1996, what is the difference between the Value added (constant 2005 US$) of Bulgaria and Value added (constant 2005 US$) of Nepal?
Ensure brevity in your answer.  1.17e+1. In the year 1997, what is the difference between the Value added (constant 2005 US$) of Bahamas and Value added (constant 2005 US$) of Belarus?
Your answer should be very brief. -2.57e+09. In the year 1997, what is the difference between the Value added (constant 2005 US$) in Bahamas and Value added (constant 2005 US$) in Bulgaria?
Make the answer very short. -8.45e+09. In the year 1997, what is the difference between the Value added (constant 2005 US$) of Bahamas and Value added (constant 2005 US$) of Nepal?
Your answer should be compact. 2.10e+09. In the year 1997, what is the difference between the Value added (constant 2005 US$) in Belarus and Value added (constant 2005 US$) in Bulgaria?
Keep it short and to the point. -5.88e+09. In the year 1997, what is the difference between the Value added (constant 2005 US$) in Belarus and Value added (constant 2005 US$) in Nepal?
Offer a terse response. 4.66e+09. In the year 1997, what is the difference between the Value added (constant 2005 US$) in Bulgaria and Value added (constant 2005 US$) in Nepal?
Give a very brief answer. 1.05e+1. What is the ratio of the Value added (constant 2005 US$) in Bahamas in 1991 to that in 1992?
Provide a short and direct response. 0.97. What is the ratio of the Value added (constant 2005 US$) of Belarus in 1991 to that in 1992?
Offer a very short reply. 1.17. What is the ratio of the Value added (constant 2005 US$) of Bulgaria in 1991 to that in 1992?
Ensure brevity in your answer.  1.37. What is the ratio of the Value added (constant 2005 US$) of Nepal in 1991 to that in 1992?
Make the answer very short. 0.94. What is the ratio of the Value added (constant 2005 US$) of Bahamas in 1991 to that in 1993?
Provide a short and direct response. 0.94. What is the ratio of the Value added (constant 2005 US$) in Belarus in 1991 to that in 1993?
Offer a terse response. 1.29. What is the ratio of the Value added (constant 2005 US$) of Bulgaria in 1991 to that in 1993?
Offer a terse response. 1.36. What is the ratio of the Value added (constant 2005 US$) in Nepal in 1991 to that in 1993?
Provide a succinct answer. 0.88. What is the ratio of the Value added (constant 2005 US$) in Bahamas in 1991 to that in 1994?
Your answer should be very brief. 0.93. What is the ratio of the Value added (constant 2005 US$) of Belarus in 1991 to that in 1994?
Offer a terse response. 1.25. What is the ratio of the Value added (constant 2005 US$) in Bulgaria in 1991 to that in 1994?
Offer a terse response. 1.4. What is the ratio of the Value added (constant 2005 US$) in Nepal in 1991 to that in 1994?
Provide a short and direct response. 0.82. What is the ratio of the Value added (constant 2005 US$) of Bahamas in 1991 to that in 1995?
Give a very brief answer. 0.89. What is the ratio of the Value added (constant 2005 US$) in Belarus in 1991 to that in 1995?
Keep it short and to the point. 1.46. What is the ratio of the Value added (constant 2005 US$) of Bulgaria in 1991 to that in 1995?
Provide a short and direct response. 1.35. What is the ratio of the Value added (constant 2005 US$) of Nepal in 1991 to that in 1995?
Ensure brevity in your answer.  0.78. What is the ratio of the Value added (constant 2005 US$) in Bahamas in 1991 to that in 1996?
Your response must be concise. 0.85. What is the ratio of the Value added (constant 2005 US$) of Belarus in 1991 to that in 1996?
Your response must be concise. 1.43. What is the ratio of the Value added (constant 2005 US$) of Bulgaria in 1991 to that in 1996?
Ensure brevity in your answer.  0.95. What is the ratio of the Value added (constant 2005 US$) of Nepal in 1991 to that in 1996?
Keep it short and to the point. 0.74. What is the ratio of the Value added (constant 2005 US$) of Bahamas in 1991 to that in 1997?
Your answer should be very brief. 1.01. What is the ratio of the Value added (constant 2005 US$) of Belarus in 1991 to that in 1997?
Offer a terse response. 1.26. What is the ratio of the Value added (constant 2005 US$) in Bulgaria in 1991 to that in 1997?
Offer a terse response. 1.02. What is the ratio of the Value added (constant 2005 US$) of Nepal in 1991 to that in 1997?
Ensure brevity in your answer.  0.71. What is the ratio of the Value added (constant 2005 US$) in Bahamas in 1992 to that in 1993?
Provide a succinct answer. 0.97. What is the ratio of the Value added (constant 2005 US$) in Belarus in 1992 to that in 1993?
Make the answer very short. 1.1. What is the ratio of the Value added (constant 2005 US$) in Bulgaria in 1992 to that in 1993?
Ensure brevity in your answer.  0.99. What is the ratio of the Value added (constant 2005 US$) of Nepal in 1992 to that in 1993?
Provide a short and direct response. 0.94. What is the ratio of the Value added (constant 2005 US$) in Bahamas in 1992 to that in 1994?
Give a very brief answer. 0.96. What is the ratio of the Value added (constant 2005 US$) of Belarus in 1992 to that in 1994?
Offer a very short reply. 1.07. What is the ratio of the Value added (constant 2005 US$) in Bulgaria in 1992 to that in 1994?
Your answer should be compact. 1.03. What is the ratio of the Value added (constant 2005 US$) of Bahamas in 1992 to that in 1995?
Make the answer very short. 0.91. What is the ratio of the Value added (constant 2005 US$) in Belarus in 1992 to that in 1995?
Give a very brief answer. 1.25. What is the ratio of the Value added (constant 2005 US$) of Bulgaria in 1992 to that in 1995?
Provide a short and direct response. 0.99. What is the ratio of the Value added (constant 2005 US$) of Nepal in 1992 to that in 1995?
Offer a terse response. 0.83. What is the ratio of the Value added (constant 2005 US$) in Bahamas in 1992 to that in 1996?
Provide a succinct answer. 0.88. What is the ratio of the Value added (constant 2005 US$) of Belarus in 1992 to that in 1996?
Ensure brevity in your answer.  1.22. What is the ratio of the Value added (constant 2005 US$) of Bulgaria in 1992 to that in 1996?
Make the answer very short. 0.69. What is the ratio of the Value added (constant 2005 US$) in Nepal in 1992 to that in 1996?
Your answer should be compact. 0.79. What is the ratio of the Value added (constant 2005 US$) of Bahamas in 1992 to that in 1997?
Provide a short and direct response. 1.04. What is the ratio of the Value added (constant 2005 US$) of Belarus in 1992 to that in 1997?
Make the answer very short. 1.08. What is the ratio of the Value added (constant 2005 US$) of Bulgaria in 1992 to that in 1997?
Offer a terse response. 0.75. What is the ratio of the Value added (constant 2005 US$) in Nepal in 1992 to that in 1997?
Offer a very short reply. 0.75. What is the ratio of the Value added (constant 2005 US$) of Belarus in 1993 to that in 1994?
Provide a short and direct response. 0.97. What is the ratio of the Value added (constant 2005 US$) in Bulgaria in 1993 to that in 1994?
Keep it short and to the point. 1.03. What is the ratio of the Value added (constant 2005 US$) in Nepal in 1993 to that in 1994?
Provide a short and direct response. 0.93. What is the ratio of the Value added (constant 2005 US$) of Bahamas in 1993 to that in 1995?
Ensure brevity in your answer.  0.94. What is the ratio of the Value added (constant 2005 US$) of Belarus in 1993 to that in 1995?
Offer a terse response. 1.14. What is the ratio of the Value added (constant 2005 US$) of Nepal in 1993 to that in 1995?
Your response must be concise. 0.89. What is the ratio of the Value added (constant 2005 US$) in Bahamas in 1993 to that in 1996?
Your response must be concise. 0.91. What is the ratio of the Value added (constant 2005 US$) of Belarus in 1993 to that in 1996?
Offer a terse response. 1.11. What is the ratio of the Value added (constant 2005 US$) of Bulgaria in 1993 to that in 1996?
Provide a short and direct response. 0.7. What is the ratio of the Value added (constant 2005 US$) of Nepal in 1993 to that in 1996?
Offer a very short reply. 0.84. What is the ratio of the Value added (constant 2005 US$) in Bahamas in 1993 to that in 1997?
Offer a terse response. 1.07. What is the ratio of the Value added (constant 2005 US$) in Belarus in 1993 to that in 1997?
Give a very brief answer. 0.98. What is the ratio of the Value added (constant 2005 US$) in Bulgaria in 1993 to that in 1997?
Provide a short and direct response. 0.75. What is the ratio of the Value added (constant 2005 US$) in Nepal in 1993 to that in 1997?
Provide a short and direct response. 0.8. What is the ratio of the Value added (constant 2005 US$) of Bahamas in 1994 to that in 1995?
Make the answer very short. 0.95. What is the ratio of the Value added (constant 2005 US$) in Bulgaria in 1994 to that in 1995?
Give a very brief answer. 0.96. What is the ratio of the Value added (constant 2005 US$) of Nepal in 1994 to that in 1995?
Your answer should be compact. 0.95. What is the ratio of the Value added (constant 2005 US$) in Bahamas in 1994 to that in 1996?
Provide a succinct answer. 0.91. What is the ratio of the Value added (constant 2005 US$) in Belarus in 1994 to that in 1996?
Ensure brevity in your answer.  1.15. What is the ratio of the Value added (constant 2005 US$) of Bulgaria in 1994 to that in 1996?
Keep it short and to the point. 0.67. What is the ratio of the Value added (constant 2005 US$) of Nepal in 1994 to that in 1996?
Ensure brevity in your answer.  0.9. What is the ratio of the Value added (constant 2005 US$) in Bahamas in 1994 to that in 1997?
Give a very brief answer. 1.08. What is the ratio of the Value added (constant 2005 US$) in Belarus in 1994 to that in 1997?
Offer a very short reply. 1.01. What is the ratio of the Value added (constant 2005 US$) of Bulgaria in 1994 to that in 1997?
Your answer should be compact. 0.73. What is the ratio of the Value added (constant 2005 US$) of Nepal in 1994 to that in 1997?
Your response must be concise. 0.86. What is the ratio of the Value added (constant 2005 US$) in Bahamas in 1995 to that in 1996?
Provide a succinct answer. 0.96. What is the ratio of the Value added (constant 2005 US$) in Belarus in 1995 to that in 1996?
Offer a terse response. 0.98. What is the ratio of the Value added (constant 2005 US$) of Bulgaria in 1995 to that in 1996?
Provide a short and direct response. 0.7. What is the ratio of the Value added (constant 2005 US$) in Nepal in 1995 to that in 1996?
Ensure brevity in your answer.  0.95. What is the ratio of the Value added (constant 2005 US$) in Bahamas in 1995 to that in 1997?
Offer a very short reply. 1.14. What is the ratio of the Value added (constant 2005 US$) in Belarus in 1995 to that in 1997?
Your answer should be compact. 0.86. What is the ratio of the Value added (constant 2005 US$) of Bulgaria in 1995 to that in 1997?
Provide a short and direct response. 0.76. What is the ratio of the Value added (constant 2005 US$) in Nepal in 1995 to that in 1997?
Offer a very short reply. 0.9. What is the ratio of the Value added (constant 2005 US$) of Bahamas in 1996 to that in 1997?
Provide a succinct answer. 1.18. What is the ratio of the Value added (constant 2005 US$) of Belarus in 1996 to that in 1997?
Offer a terse response. 0.88. What is the ratio of the Value added (constant 2005 US$) of Bulgaria in 1996 to that in 1997?
Offer a terse response. 1.08. What is the ratio of the Value added (constant 2005 US$) in Nepal in 1996 to that in 1997?
Your response must be concise. 0.95. What is the difference between the highest and the second highest Value added (constant 2005 US$) in Bahamas?
Keep it short and to the point. 1.98e+08. What is the difference between the highest and the second highest Value added (constant 2005 US$) of Belarus?
Offer a terse response. 1.31e+09. What is the difference between the highest and the second highest Value added (constant 2005 US$) in Bulgaria?
Ensure brevity in your answer.  7.64e+08. What is the difference between the highest and the second highest Value added (constant 2005 US$) in Nepal?
Offer a very short reply. 1.18e+08. What is the difference between the highest and the lowest Value added (constant 2005 US$) of Bahamas?
Give a very brief answer. 8.37e+08. What is the difference between the highest and the lowest Value added (constant 2005 US$) of Belarus?
Make the answer very short. 2.85e+09. What is the difference between the highest and the lowest Value added (constant 2005 US$) of Bulgaria?
Your response must be concise. 4.60e+09. What is the difference between the highest and the lowest Value added (constant 2005 US$) of Nepal?
Give a very brief answer. 7.42e+08. 